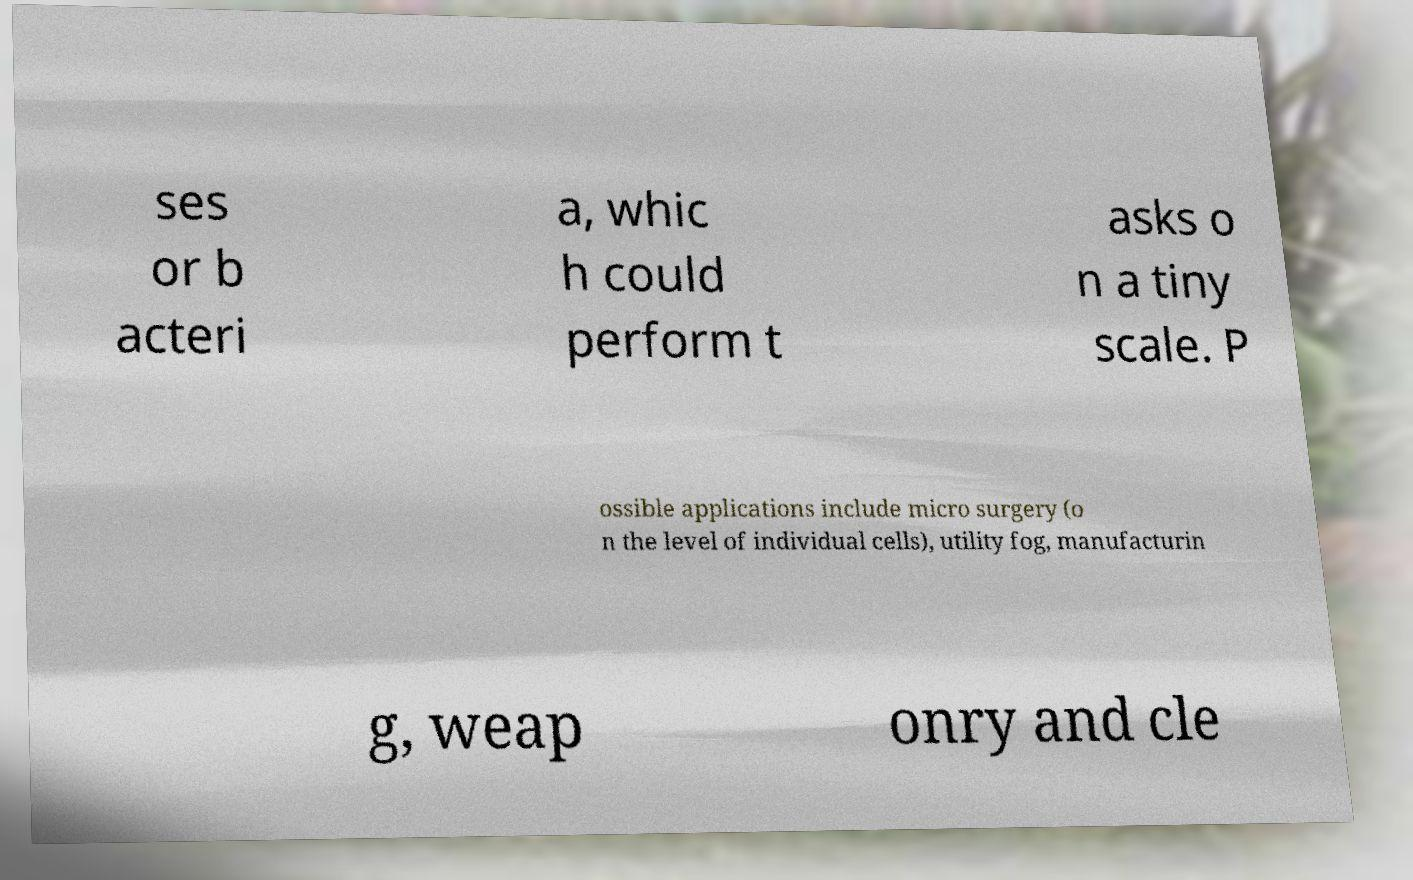Could you extract and type out the text from this image? ses or b acteri a, whic h could perform t asks o n a tiny scale. P ossible applications include micro surgery (o n the level of individual cells), utility fog, manufacturin g, weap onry and cle 